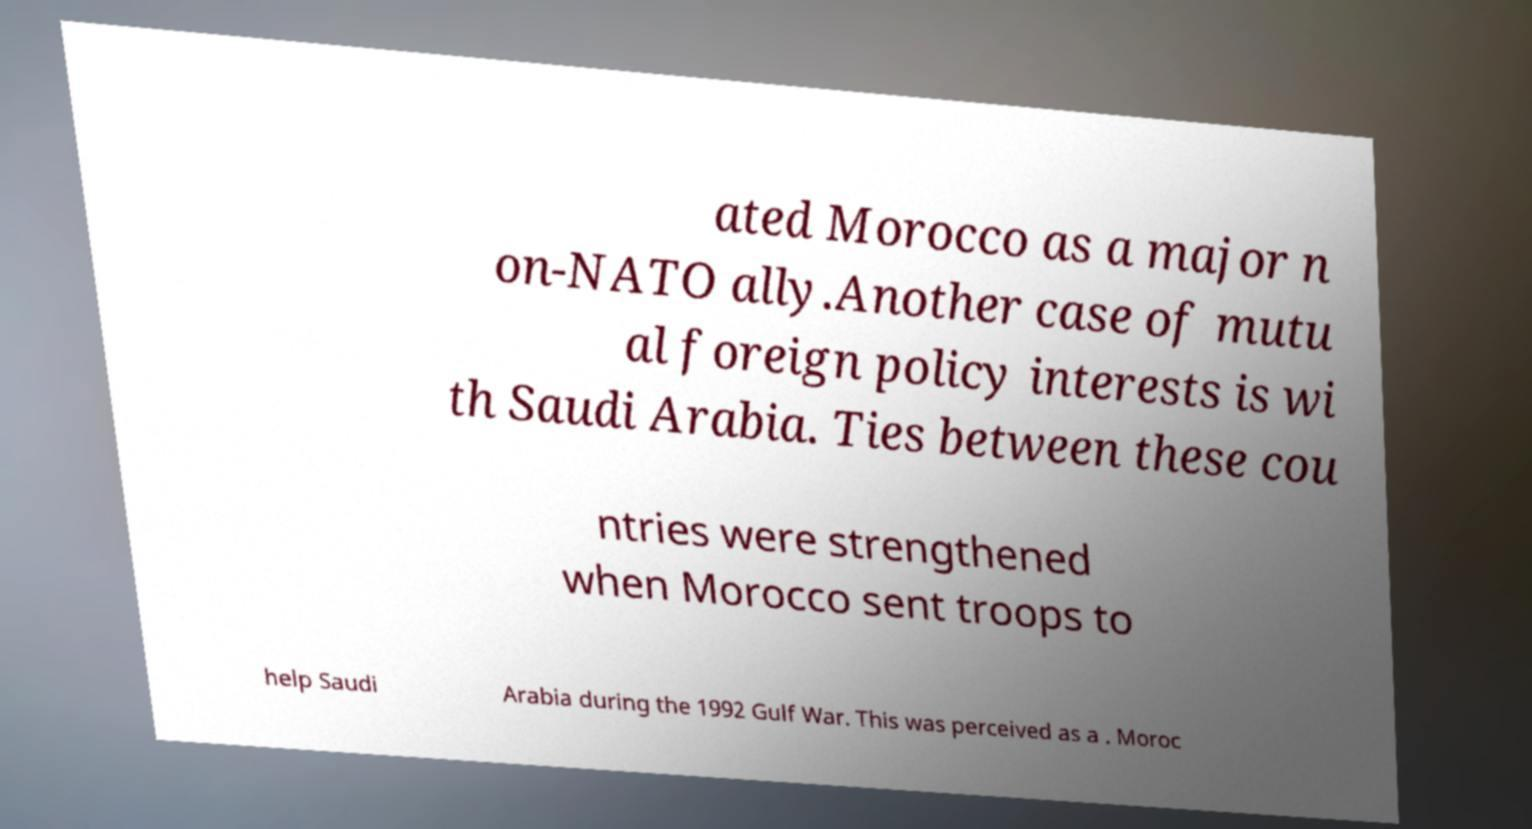Can you read and provide the text displayed in the image?This photo seems to have some interesting text. Can you extract and type it out for me? ated Morocco as a major n on-NATO ally.Another case of mutu al foreign policy interests is wi th Saudi Arabia. Ties between these cou ntries were strengthened when Morocco sent troops to help Saudi Arabia during the 1992 Gulf War. This was perceived as a . Moroc 